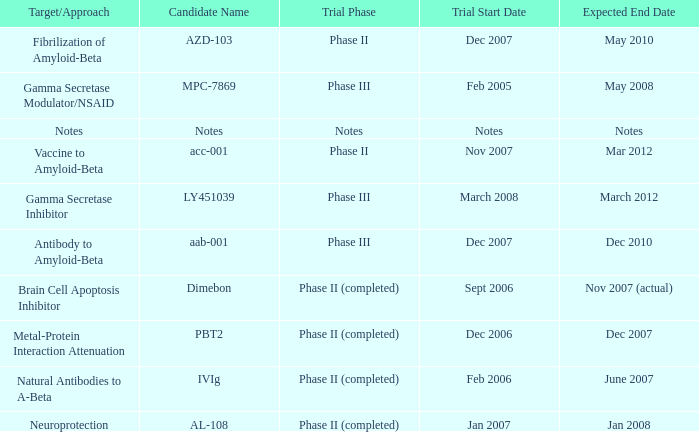Would you mind parsing the complete table? {'header': ['Target/Approach', 'Candidate Name', 'Trial Phase', 'Trial Start Date', 'Expected End Date'], 'rows': [['Fibrilization of Amyloid-Beta', 'AZD-103', 'Phase II', 'Dec 2007', 'May 2010'], ['Gamma Secretase Modulator/NSAID', 'MPC-7869', 'Phase III', 'Feb 2005', 'May 2008'], ['Notes', 'Notes', 'Notes', 'Notes', 'Notes'], ['Vaccine to Amyloid-Beta', 'acc-001', 'Phase II', 'Nov 2007', 'Mar 2012'], ['Gamma Secretase Inhibitor', 'LY451039', 'Phase III', 'March 2008', 'March 2012'], ['Antibody to Amyloid-Beta', 'aab-001', 'Phase III', 'Dec 2007', 'Dec 2010'], ['Brain Cell Apoptosis Inhibitor', 'Dimebon', 'Phase II (completed)', 'Sept 2006', 'Nov 2007 (actual)'], ['Metal-Protein Interaction Attenuation', 'PBT2', 'Phase II (completed)', 'Dec 2006', 'Dec 2007'], ['Natural Antibodies to A-Beta', 'IVIg', 'Phase II (completed)', 'Feb 2006', 'June 2007'], ['Neuroprotection', 'AL-108', 'Phase II (completed)', 'Jan 2007', 'Jan 2008']]} What is Trial Start Date, when Candidate Name is Notes? Notes. 